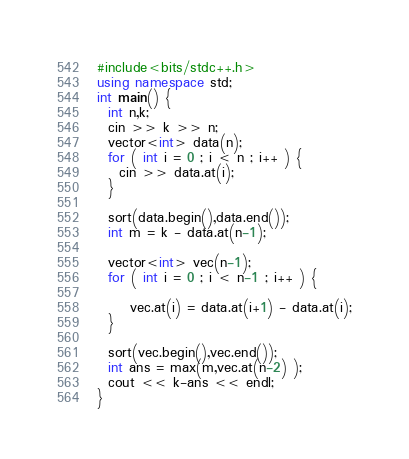<code> <loc_0><loc_0><loc_500><loc_500><_C++_>#include<bits/stdc++.h>
using namespace std;
int main() {
  int n,k;
  cin >> k >> n;
  vector<int> data(n);
  for ( int i = 0 ; i < n ; i++ ) {
    cin >> data.at(i);
  }
  
  sort(data.begin(),data.end());
  int m = k - data.at(n-1);
  
  vector<int> vec(n-1);
  for ( int i = 0 ; i < n-1 ; i++ ) {
    
      vec.at(i) = data.at(i+1) - data.at(i);
  }
  
  sort(vec.begin(),vec.end());
  int ans = max(m,vec.at(n-2) );
  cout << k-ans << endl;
}</code> 